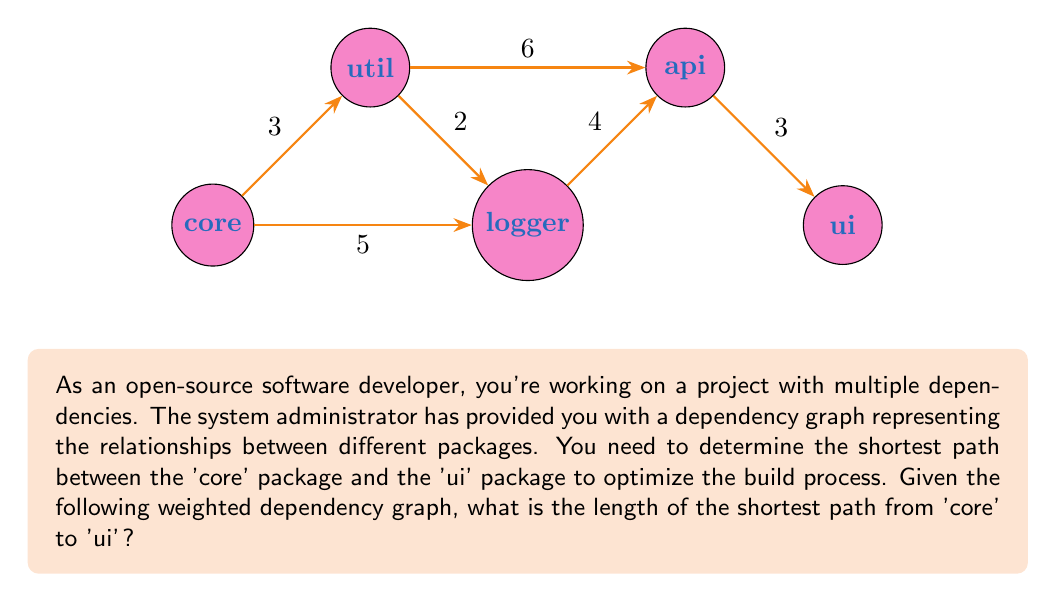Provide a solution to this math problem. To solve this problem, we'll use Dijkstra's algorithm to find the shortest path from 'core' to 'ui' in the weighted dependency graph.

Steps:

1) Initialize distances:
   core: 0
   util: ∞
   logger: ∞
   api: ∞
   ui: ∞

2) Start from 'core' and update its neighbors:
   util: min(∞, 0 + 3) = 3
   logger: min(∞, 0 + 5) = 5

3) Select the node with the smallest distance (util) and update its neighbors:
   logger: min(5, 3 + 2) = 5
   api: min(∞, 3 + 6) = 9

4) Select the next smallest (logger) and update its neighbors:
   api: min(9, 5 + 4) = 9
   ui: min(∞, 5 + 7) = 12 (7 is the sum of 4 and 3 from logger to ui)

5) Select api and update its neighbors:
   ui: min(12, 9 + 3) = 12

6) The algorithm terminates as all nodes have been visited.

The shortest path from 'core' to 'ui' is:
core → logger → api → ui

The length of this path is:
$$ 5 + 4 + 3 = 12 $$
Answer: 12 